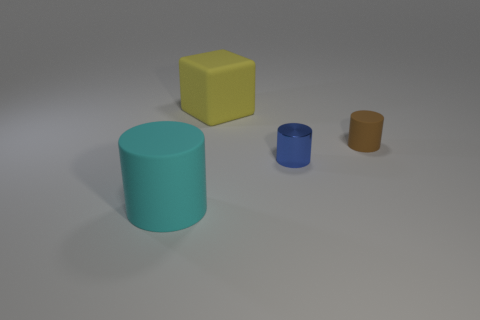Subtract all tiny cylinders. How many cylinders are left? 1 Add 4 tiny gray shiny objects. How many objects exist? 8 Subtract all cylinders. How many objects are left? 1 Subtract all big matte objects. Subtract all small blue metallic things. How many objects are left? 1 Add 4 large rubber things. How many large rubber things are left? 6 Add 3 big yellow matte objects. How many big yellow matte objects exist? 4 Subtract 0 yellow cylinders. How many objects are left? 4 